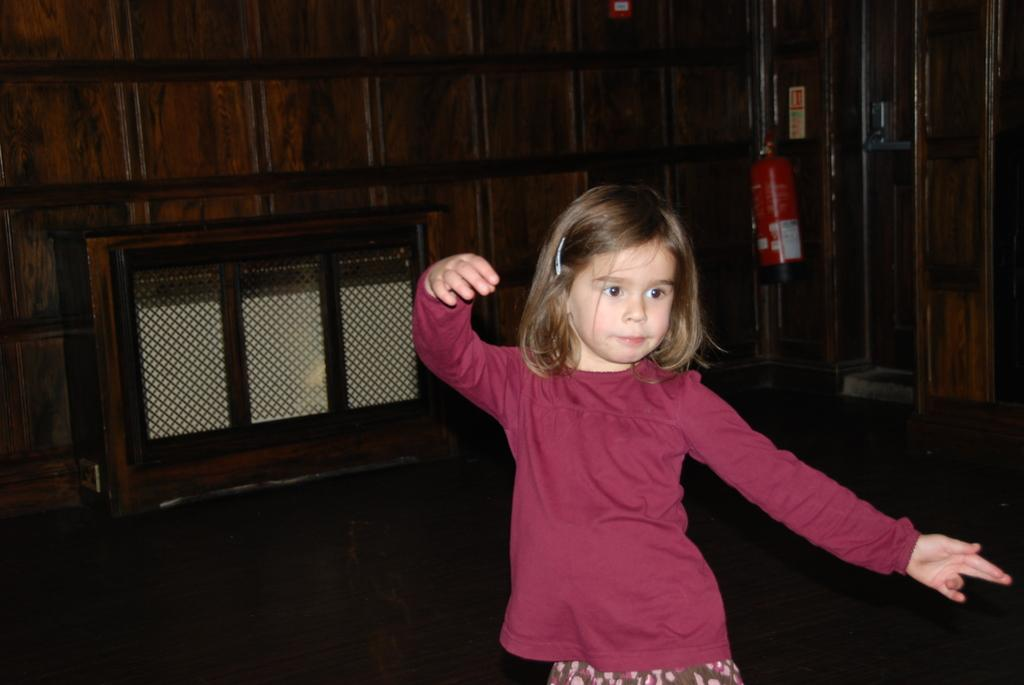Who is the main subject in the image? There is a girl in the image. What can be seen in the background of the image? There is a wooden wall and a fire extinguisher in the background of the image. What type of match is the girl holding in the image? There is no match present in the image; the girl is not holding anything. 